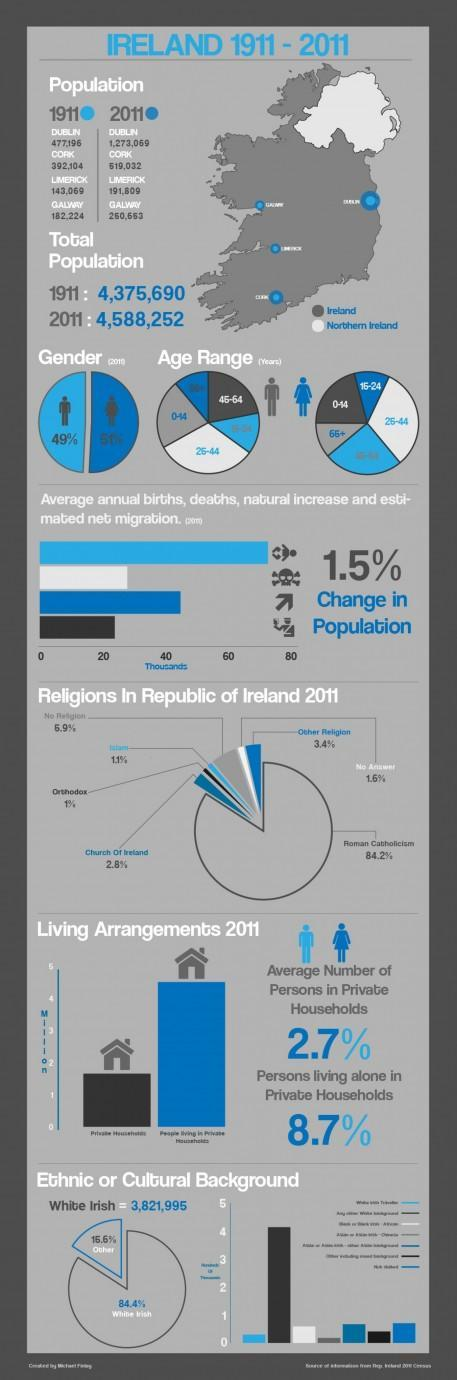What is the population of limerick city in 1911?
Answer the question with a short phrase. 143,069 What is the population of Dublin in 2011? 1,273,069 What percentage of people are Roman Catholics in Ireland in 2011? 84.2% What is the percentage of male population in Ireland in 2011? 49% What is the percentage of female population in Ireland in 2011? 51% What is the population of Cork city of Ireland in 1911? 392,104 What percentage of people followed orthodox religion in Ireland in 2011? 1% What is the ethnicity of the majority people in Ireland in 2011? White Irish 